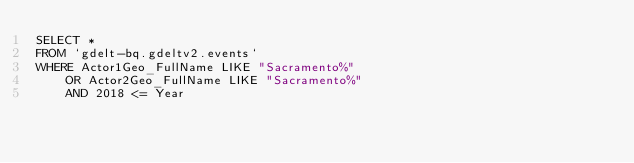Convert code to text. <code><loc_0><loc_0><loc_500><loc_500><_SQL_>SELECT *
FROM `gdelt-bq.gdeltv2.events`
WHERE Actor1Geo_FullName LIKE "Sacramento%"
    OR Actor2Geo_FullName LIKE "Sacramento%"
    AND 2018 <= Year

</code> 